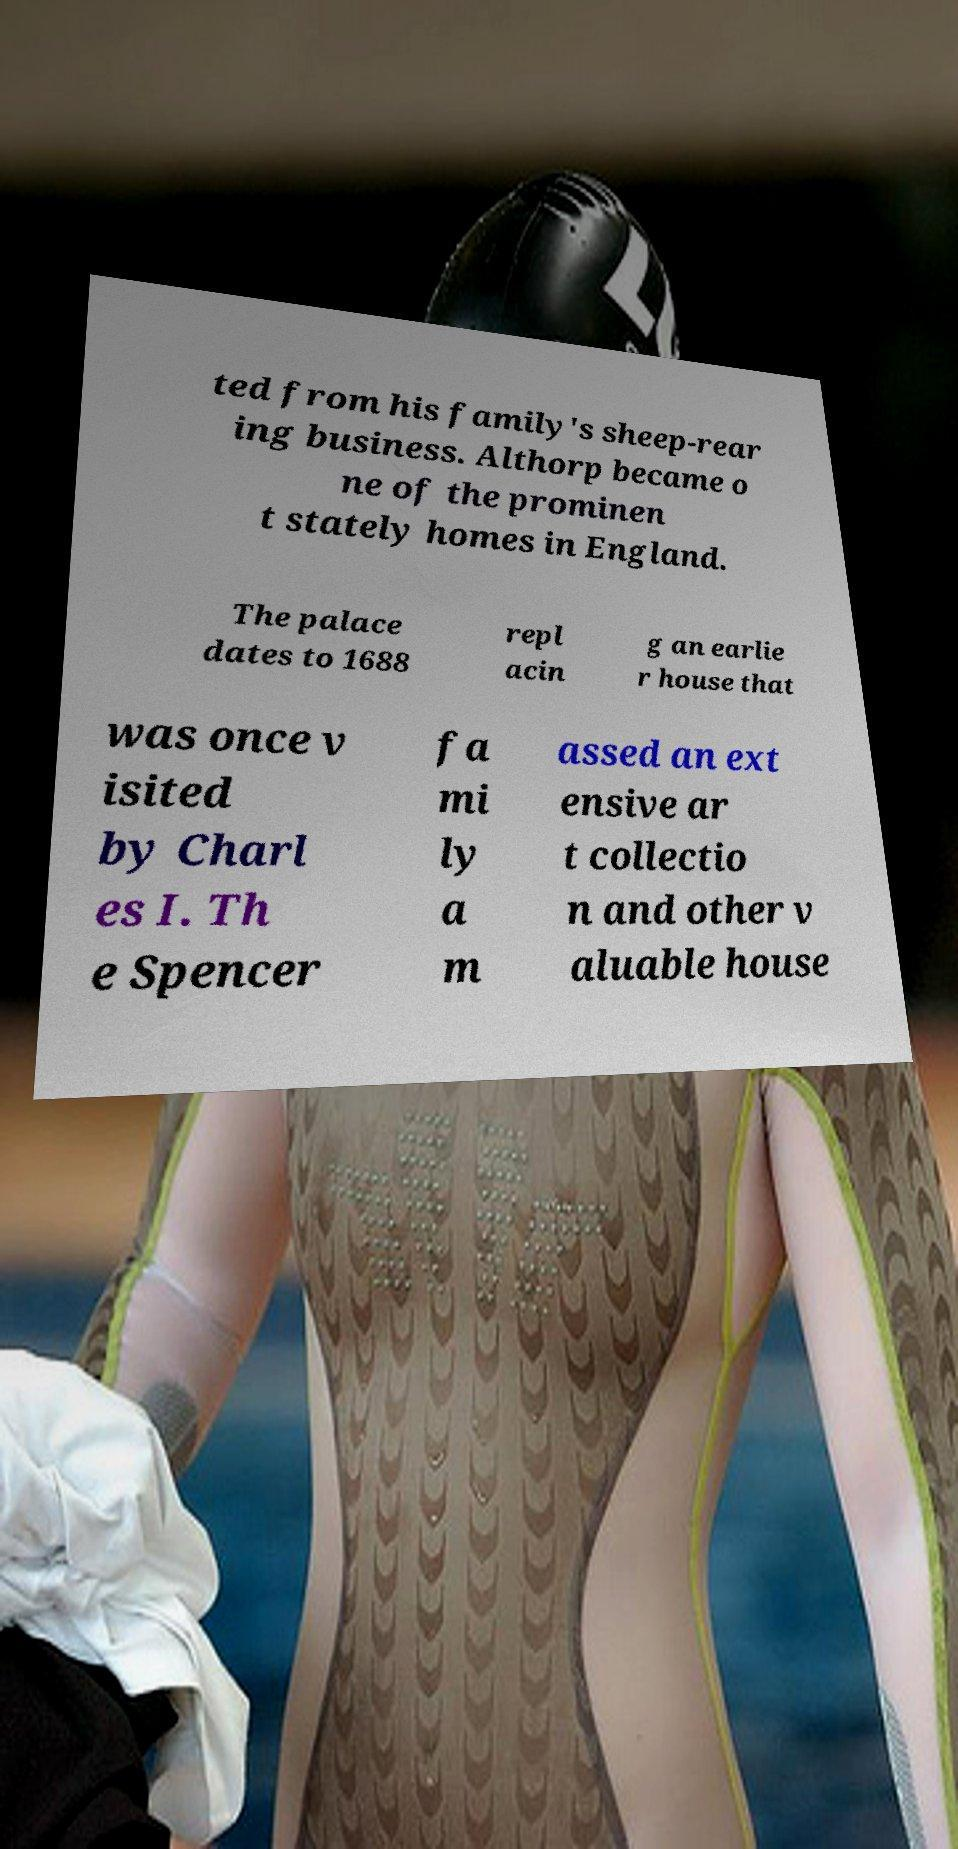I need the written content from this picture converted into text. Can you do that? ted from his family's sheep-rear ing business. Althorp became o ne of the prominen t stately homes in England. The palace dates to 1688 repl acin g an earlie r house that was once v isited by Charl es I. Th e Spencer fa mi ly a m assed an ext ensive ar t collectio n and other v aluable house 